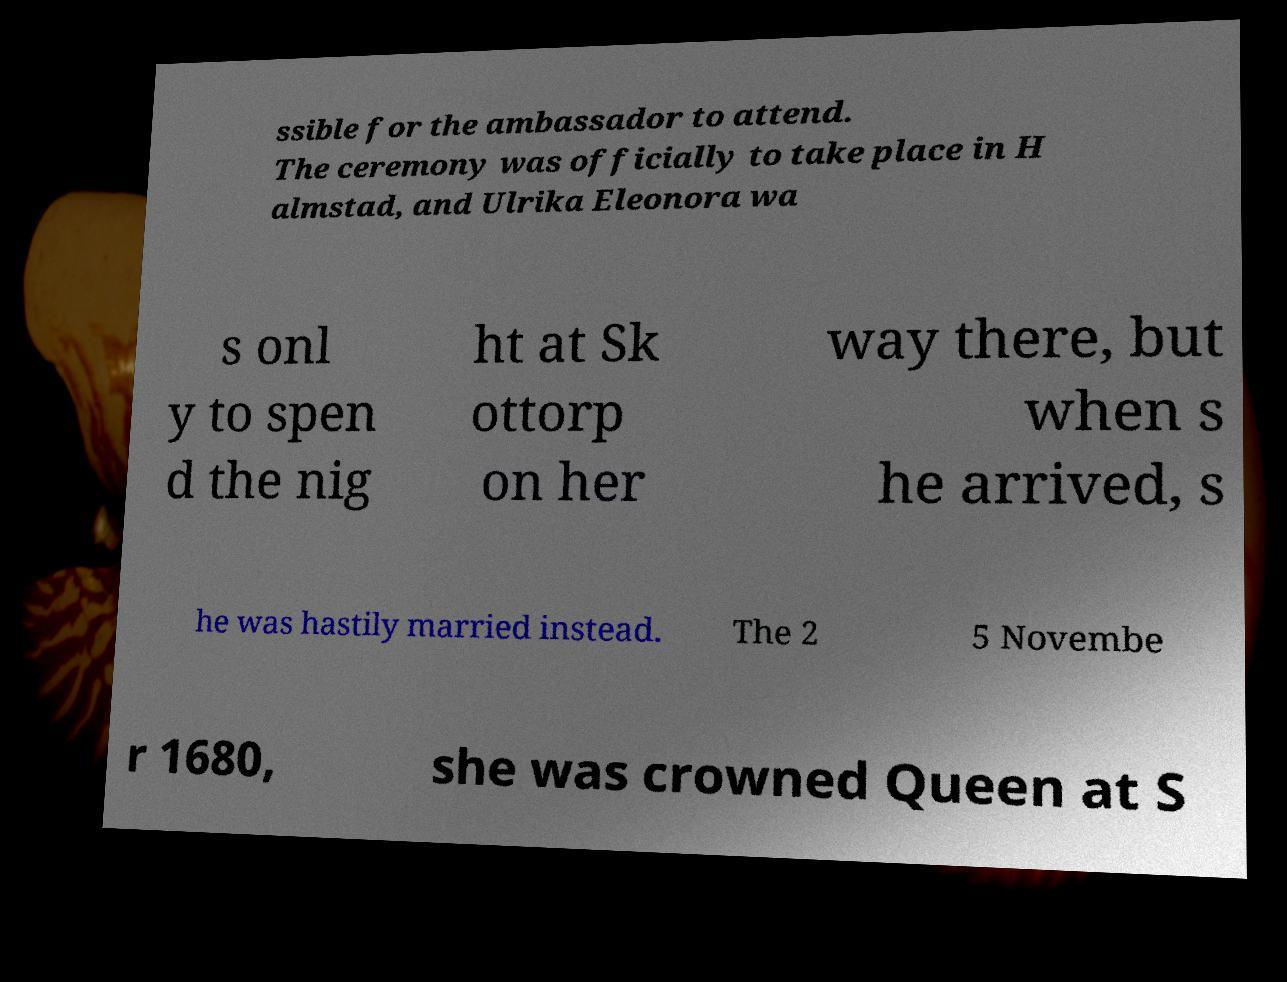I need the written content from this picture converted into text. Can you do that? ssible for the ambassador to attend. The ceremony was officially to take place in H almstad, and Ulrika Eleonora wa s onl y to spen d the nig ht at Sk ottorp on her way there, but when s he arrived, s he was hastily married instead. The 2 5 Novembe r 1680, she was crowned Queen at S 